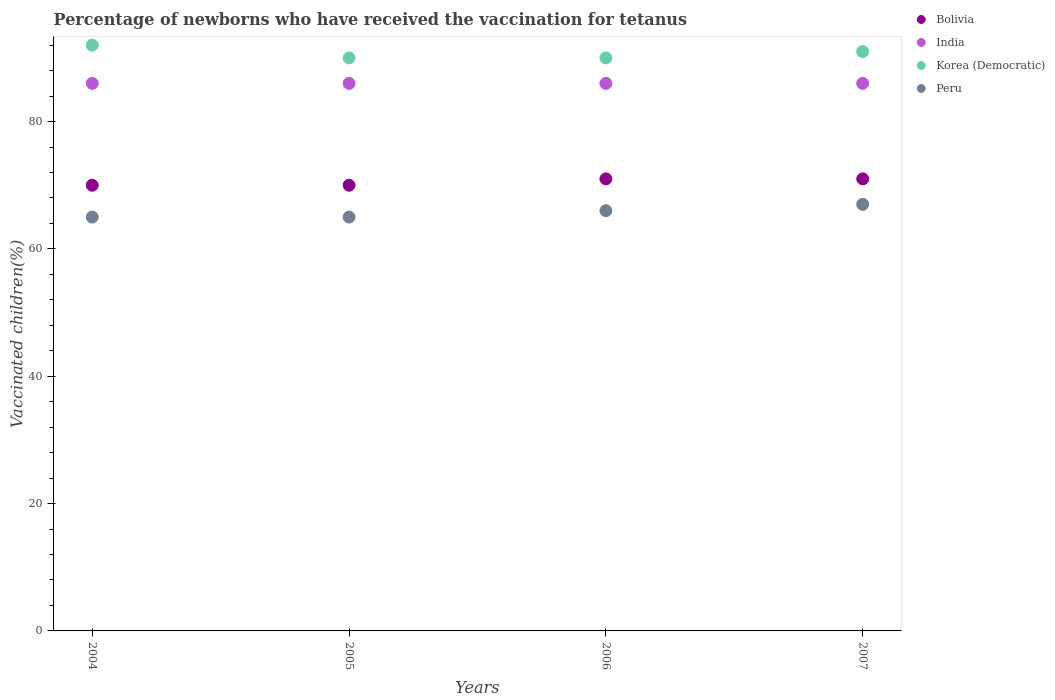How many different coloured dotlines are there?
Give a very brief answer. 4. What is the percentage of vaccinated children in India in 2005?
Ensure brevity in your answer.  86. What is the total percentage of vaccinated children in Peru in the graph?
Keep it short and to the point. 263. What is the difference between the percentage of vaccinated children in Bolivia in 2006 and that in 2007?
Give a very brief answer. 0. What is the average percentage of vaccinated children in Peru per year?
Ensure brevity in your answer.  65.75. Is the percentage of vaccinated children in Bolivia in 2004 less than that in 2007?
Provide a short and direct response. Yes. What is the difference between the highest and the second highest percentage of vaccinated children in Peru?
Your answer should be compact. 1. Is the sum of the percentage of vaccinated children in Bolivia in 2006 and 2007 greater than the maximum percentage of vaccinated children in Peru across all years?
Make the answer very short. Yes. Is it the case that in every year, the sum of the percentage of vaccinated children in Bolivia and percentage of vaccinated children in India  is greater than the percentage of vaccinated children in Korea (Democratic)?
Provide a short and direct response. Yes. Does the percentage of vaccinated children in India monotonically increase over the years?
Your response must be concise. No. Is the percentage of vaccinated children in Korea (Democratic) strictly greater than the percentage of vaccinated children in Bolivia over the years?
Your answer should be compact. Yes. How many dotlines are there?
Your answer should be very brief. 4. What is the difference between two consecutive major ticks on the Y-axis?
Give a very brief answer. 20. Does the graph contain grids?
Give a very brief answer. No. How many legend labels are there?
Offer a very short reply. 4. How are the legend labels stacked?
Make the answer very short. Vertical. What is the title of the graph?
Ensure brevity in your answer.  Percentage of newborns who have received the vaccination for tetanus. Does "Guatemala" appear as one of the legend labels in the graph?
Give a very brief answer. No. What is the label or title of the X-axis?
Your response must be concise. Years. What is the label or title of the Y-axis?
Provide a succinct answer. Vaccinated children(%). What is the Vaccinated children(%) of Korea (Democratic) in 2004?
Make the answer very short. 92. What is the Vaccinated children(%) in Peru in 2004?
Provide a succinct answer. 65. What is the Vaccinated children(%) of Peru in 2005?
Your answer should be very brief. 65. What is the Vaccinated children(%) in India in 2006?
Give a very brief answer. 86. What is the Vaccinated children(%) in Korea (Democratic) in 2006?
Make the answer very short. 90. What is the Vaccinated children(%) in Korea (Democratic) in 2007?
Provide a succinct answer. 91. Across all years, what is the maximum Vaccinated children(%) in Bolivia?
Offer a very short reply. 71. Across all years, what is the maximum Vaccinated children(%) of Korea (Democratic)?
Provide a succinct answer. 92. Across all years, what is the minimum Vaccinated children(%) of Bolivia?
Make the answer very short. 70. Across all years, what is the minimum Vaccinated children(%) of India?
Your answer should be compact. 86. What is the total Vaccinated children(%) in Bolivia in the graph?
Offer a terse response. 282. What is the total Vaccinated children(%) of India in the graph?
Offer a very short reply. 344. What is the total Vaccinated children(%) of Korea (Democratic) in the graph?
Provide a succinct answer. 363. What is the total Vaccinated children(%) of Peru in the graph?
Keep it short and to the point. 263. What is the difference between the Vaccinated children(%) in Bolivia in 2004 and that in 2005?
Your response must be concise. 0. What is the difference between the Vaccinated children(%) in India in 2004 and that in 2005?
Provide a short and direct response. 0. What is the difference between the Vaccinated children(%) in Bolivia in 2004 and that in 2006?
Your answer should be very brief. -1. What is the difference between the Vaccinated children(%) in Korea (Democratic) in 2004 and that in 2006?
Keep it short and to the point. 2. What is the difference between the Vaccinated children(%) of Korea (Democratic) in 2004 and that in 2007?
Ensure brevity in your answer.  1. What is the difference between the Vaccinated children(%) in Bolivia in 2005 and that in 2006?
Your answer should be compact. -1. What is the difference between the Vaccinated children(%) in India in 2005 and that in 2006?
Your response must be concise. 0. What is the difference between the Vaccinated children(%) in Korea (Democratic) in 2005 and that in 2006?
Your answer should be compact. 0. What is the difference between the Vaccinated children(%) in Peru in 2005 and that in 2006?
Make the answer very short. -1. What is the difference between the Vaccinated children(%) in Bolivia in 2005 and that in 2007?
Make the answer very short. -1. What is the difference between the Vaccinated children(%) of India in 2005 and that in 2007?
Your answer should be compact. 0. What is the difference between the Vaccinated children(%) in Korea (Democratic) in 2005 and that in 2007?
Give a very brief answer. -1. What is the difference between the Vaccinated children(%) of Bolivia in 2006 and that in 2007?
Provide a succinct answer. 0. What is the difference between the Vaccinated children(%) of Korea (Democratic) in 2006 and that in 2007?
Offer a terse response. -1. What is the difference between the Vaccinated children(%) in Peru in 2006 and that in 2007?
Offer a very short reply. -1. What is the difference between the Vaccinated children(%) of Bolivia in 2004 and the Vaccinated children(%) of India in 2005?
Your response must be concise. -16. What is the difference between the Vaccinated children(%) of Bolivia in 2004 and the Vaccinated children(%) of Peru in 2005?
Your answer should be very brief. 5. What is the difference between the Vaccinated children(%) in India in 2004 and the Vaccinated children(%) in Korea (Democratic) in 2005?
Your answer should be very brief. -4. What is the difference between the Vaccinated children(%) of India in 2004 and the Vaccinated children(%) of Peru in 2005?
Your answer should be compact. 21. What is the difference between the Vaccinated children(%) in Korea (Democratic) in 2004 and the Vaccinated children(%) in Peru in 2005?
Give a very brief answer. 27. What is the difference between the Vaccinated children(%) in Bolivia in 2004 and the Vaccinated children(%) in India in 2006?
Give a very brief answer. -16. What is the difference between the Vaccinated children(%) in Bolivia in 2004 and the Vaccinated children(%) in Peru in 2006?
Give a very brief answer. 4. What is the difference between the Vaccinated children(%) in Bolivia in 2004 and the Vaccinated children(%) in Korea (Democratic) in 2007?
Provide a short and direct response. -21. What is the difference between the Vaccinated children(%) in India in 2004 and the Vaccinated children(%) in Korea (Democratic) in 2007?
Offer a very short reply. -5. What is the difference between the Vaccinated children(%) in Korea (Democratic) in 2005 and the Vaccinated children(%) in Peru in 2006?
Ensure brevity in your answer.  24. What is the difference between the Vaccinated children(%) of Bolivia in 2005 and the Vaccinated children(%) of Korea (Democratic) in 2007?
Offer a terse response. -21. What is the difference between the Vaccinated children(%) in Bolivia in 2005 and the Vaccinated children(%) in Peru in 2007?
Your answer should be compact. 3. What is the difference between the Vaccinated children(%) of India in 2005 and the Vaccinated children(%) of Korea (Democratic) in 2007?
Ensure brevity in your answer.  -5. What is the difference between the Vaccinated children(%) in Bolivia in 2006 and the Vaccinated children(%) in Peru in 2007?
Your answer should be compact. 4. What is the difference between the Vaccinated children(%) of India in 2006 and the Vaccinated children(%) of Peru in 2007?
Provide a succinct answer. 19. What is the average Vaccinated children(%) of Bolivia per year?
Ensure brevity in your answer.  70.5. What is the average Vaccinated children(%) of India per year?
Ensure brevity in your answer.  86. What is the average Vaccinated children(%) of Korea (Democratic) per year?
Keep it short and to the point. 90.75. What is the average Vaccinated children(%) in Peru per year?
Offer a terse response. 65.75. In the year 2004, what is the difference between the Vaccinated children(%) in Bolivia and Vaccinated children(%) in India?
Offer a terse response. -16. In the year 2004, what is the difference between the Vaccinated children(%) in Bolivia and Vaccinated children(%) in Korea (Democratic)?
Offer a very short reply. -22. In the year 2004, what is the difference between the Vaccinated children(%) in India and Vaccinated children(%) in Peru?
Give a very brief answer. 21. In the year 2005, what is the difference between the Vaccinated children(%) of Bolivia and Vaccinated children(%) of India?
Ensure brevity in your answer.  -16. In the year 2005, what is the difference between the Vaccinated children(%) in Bolivia and Vaccinated children(%) in Peru?
Offer a very short reply. 5. In the year 2005, what is the difference between the Vaccinated children(%) of India and Vaccinated children(%) of Korea (Democratic)?
Ensure brevity in your answer.  -4. In the year 2005, what is the difference between the Vaccinated children(%) in India and Vaccinated children(%) in Peru?
Offer a very short reply. 21. In the year 2005, what is the difference between the Vaccinated children(%) of Korea (Democratic) and Vaccinated children(%) of Peru?
Offer a terse response. 25. In the year 2006, what is the difference between the Vaccinated children(%) of Bolivia and Vaccinated children(%) of India?
Your answer should be very brief. -15. In the year 2006, what is the difference between the Vaccinated children(%) of Bolivia and Vaccinated children(%) of Peru?
Provide a short and direct response. 5. In the year 2007, what is the difference between the Vaccinated children(%) of Bolivia and Vaccinated children(%) of India?
Provide a short and direct response. -15. In the year 2007, what is the difference between the Vaccinated children(%) in Bolivia and Vaccinated children(%) in Korea (Democratic)?
Make the answer very short. -20. In the year 2007, what is the difference between the Vaccinated children(%) in Bolivia and Vaccinated children(%) in Peru?
Ensure brevity in your answer.  4. In the year 2007, what is the difference between the Vaccinated children(%) in India and Vaccinated children(%) in Peru?
Ensure brevity in your answer.  19. What is the ratio of the Vaccinated children(%) in India in 2004 to that in 2005?
Your response must be concise. 1. What is the ratio of the Vaccinated children(%) in Korea (Democratic) in 2004 to that in 2005?
Offer a very short reply. 1.02. What is the ratio of the Vaccinated children(%) in Peru in 2004 to that in 2005?
Give a very brief answer. 1. What is the ratio of the Vaccinated children(%) in Bolivia in 2004 to that in 2006?
Your answer should be very brief. 0.99. What is the ratio of the Vaccinated children(%) in Korea (Democratic) in 2004 to that in 2006?
Offer a terse response. 1.02. What is the ratio of the Vaccinated children(%) in Bolivia in 2004 to that in 2007?
Make the answer very short. 0.99. What is the ratio of the Vaccinated children(%) in India in 2004 to that in 2007?
Offer a very short reply. 1. What is the ratio of the Vaccinated children(%) in Peru in 2004 to that in 2007?
Give a very brief answer. 0.97. What is the ratio of the Vaccinated children(%) in Bolivia in 2005 to that in 2006?
Offer a terse response. 0.99. What is the ratio of the Vaccinated children(%) of Peru in 2005 to that in 2006?
Give a very brief answer. 0.98. What is the ratio of the Vaccinated children(%) in Bolivia in 2005 to that in 2007?
Make the answer very short. 0.99. What is the ratio of the Vaccinated children(%) in India in 2005 to that in 2007?
Provide a succinct answer. 1. What is the ratio of the Vaccinated children(%) of Peru in 2005 to that in 2007?
Provide a succinct answer. 0.97. What is the ratio of the Vaccinated children(%) in Bolivia in 2006 to that in 2007?
Your answer should be compact. 1. What is the ratio of the Vaccinated children(%) of Korea (Democratic) in 2006 to that in 2007?
Your response must be concise. 0.99. What is the ratio of the Vaccinated children(%) in Peru in 2006 to that in 2007?
Ensure brevity in your answer.  0.99. What is the difference between the highest and the second highest Vaccinated children(%) in Bolivia?
Provide a succinct answer. 0. What is the difference between the highest and the second highest Vaccinated children(%) of India?
Your answer should be compact. 0. What is the difference between the highest and the second highest Vaccinated children(%) of Peru?
Provide a short and direct response. 1. What is the difference between the highest and the lowest Vaccinated children(%) in Korea (Democratic)?
Offer a very short reply. 2. What is the difference between the highest and the lowest Vaccinated children(%) of Peru?
Your answer should be compact. 2. 